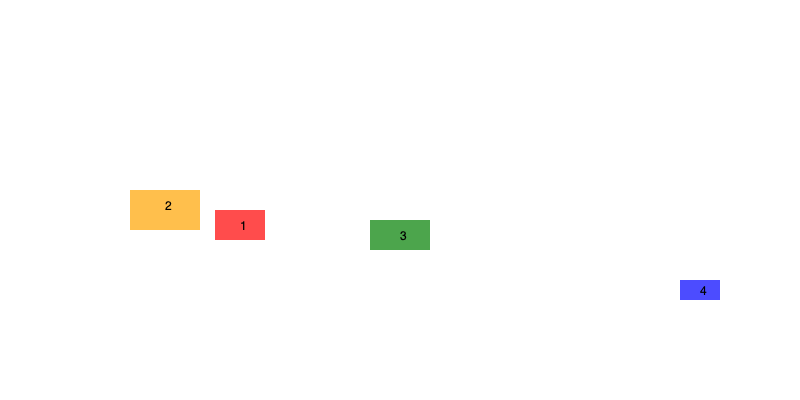As a record label executive championing reggae music, identify the region marked "1" on the map, which represents the birthplace of reggae and continues to be a significant hub for the genre's production and innovation. To answer this question, let's analyze the map and consider the history and geography of reggae music:

1. Region 1 (red) is located in the Caribbean area, which aligns with the birthplace of reggae music.

2. Reggae originated in Jamaica in the late 1960s, evolving from earlier genres like ska and rocksteady.

3. Jamaica, an island nation in the Caribbean, is geographically consistent with the location marked as Region 1 on the map.

4. The other regions highlighted on the map represent areas where reggae has gained popularity or has had significant influence:
   - Region 2 (orange): Likely represents North America, particularly the United States, where reggae gained international recognition.
   - Region 3 (green): Possibly represents Africa, especially West Africa, where reggae has had a strong influence and cultural connection.
   - Region 4 (blue): Could represent Japan or other parts of Asia where reggae has developed a dedicated following.

5. As the birthplace of reggae, Jamaica (Region 1) continues to be a major center for reggae music production, innovation, and culture.

Given the geographic location and the historical context of reggae's origins, Region 1 on the map must represent Jamaica.
Answer: Jamaica 